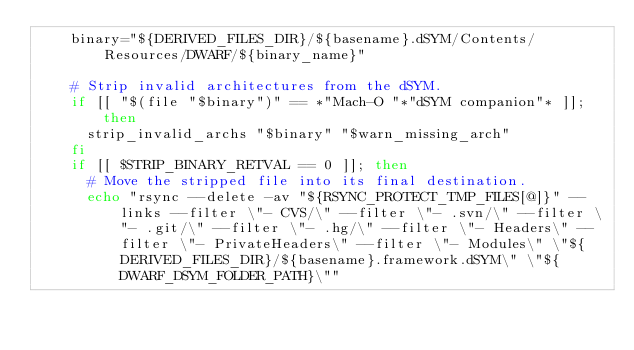<code> <loc_0><loc_0><loc_500><loc_500><_Bash_>    binary="${DERIVED_FILES_DIR}/${basename}.dSYM/Contents/Resources/DWARF/${binary_name}"

    # Strip invalid architectures from the dSYM.
    if [[ "$(file "$binary")" == *"Mach-O "*"dSYM companion"* ]]; then
      strip_invalid_archs "$binary" "$warn_missing_arch"
    fi
    if [[ $STRIP_BINARY_RETVAL == 0 ]]; then
      # Move the stripped file into its final destination.
      echo "rsync --delete -av "${RSYNC_PROTECT_TMP_FILES[@]}" --links --filter \"- CVS/\" --filter \"- .svn/\" --filter \"- .git/\" --filter \"- .hg/\" --filter \"- Headers\" --filter \"- PrivateHeaders\" --filter \"- Modules\" \"${DERIVED_FILES_DIR}/${basename}.framework.dSYM\" \"${DWARF_DSYM_FOLDER_PATH}\""</code> 